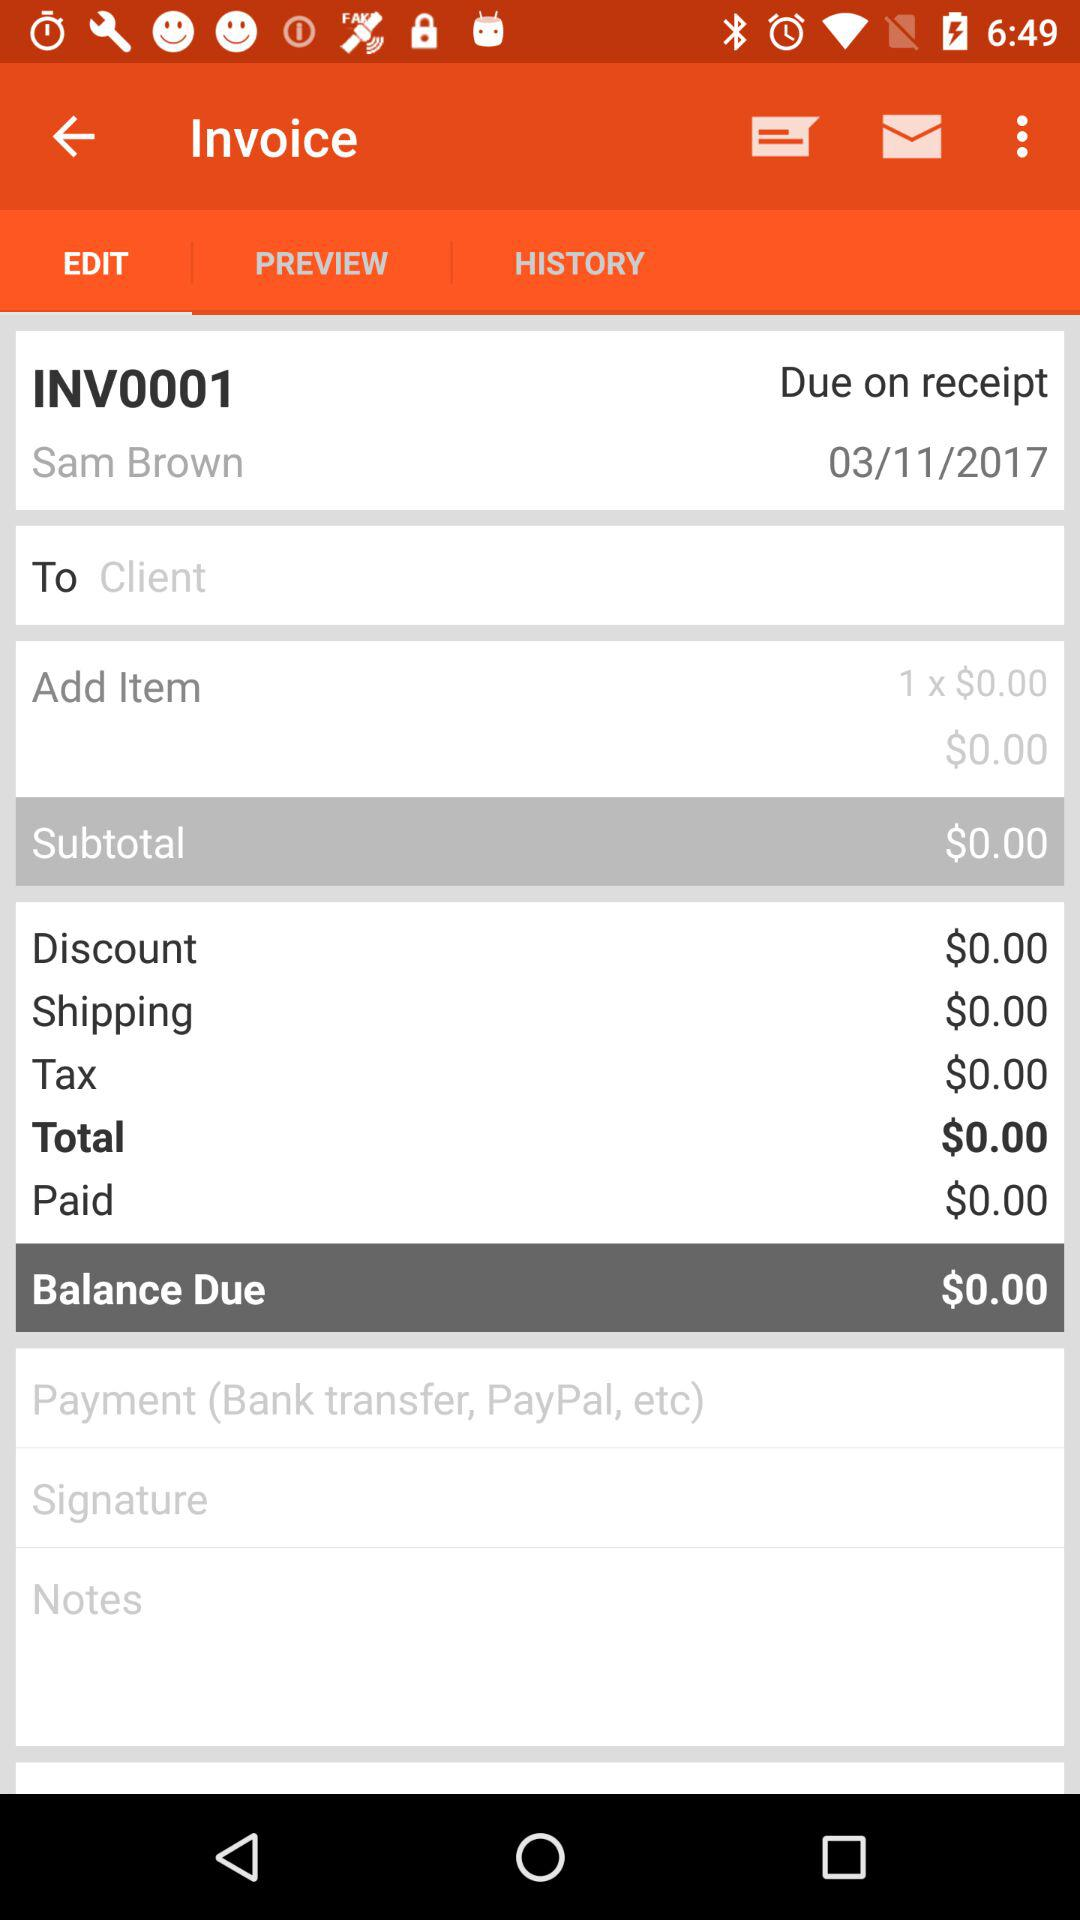Which option is selected for invoice? The selected option is "EDIT". 